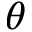<formula> <loc_0><loc_0><loc_500><loc_500>\theta</formula> 